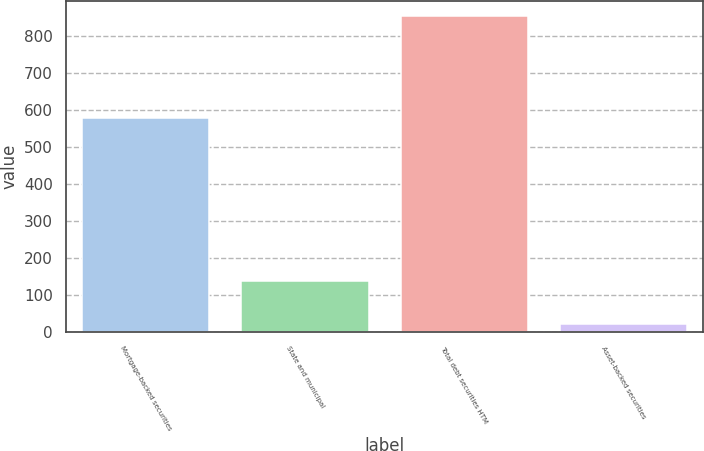Convert chart. <chart><loc_0><loc_0><loc_500><loc_500><bar_chart><fcel>Mortgage-backed securities<fcel>State and municipal<fcel>Total debt securities HTM<fcel>Asset-backed securities<nl><fcel>579<fcel>138<fcel>853<fcel>22<nl></chart> 